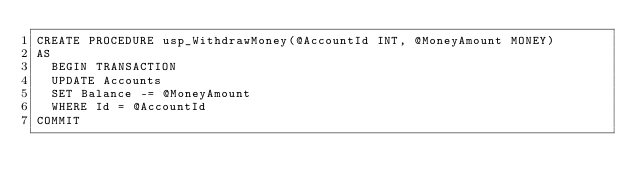Convert code to text. <code><loc_0><loc_0><loc_500><loc_500><_SQL_>CREATE PROCEDURE usp_WithdrawMoney(@AccountId INT, @MoneyAmount MONEY)
AS
  BEGIN TRANSACTION
  UPDATE Accounts
  SET Balance -= @MoneyAmount
  WHERE Id = @AccountId
COMMIT</code> 